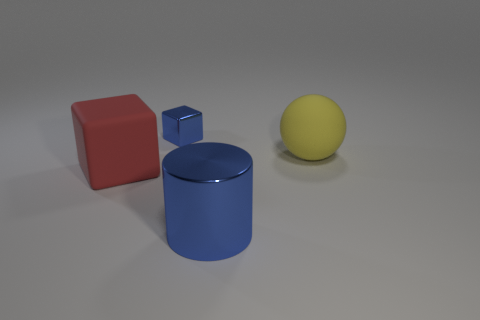Add 2 blue cubes. How many objects exist? 6 Subtract all cylinders. How many objects are left? 3 Subtract all red things. Subtract all cubes. How many objects are left? 1 Add 3 blue metallic blocks. How many blue metallic blocks are left? 4 Add 4 green things. How many green things exist? 4 Subtract 0 cyan balls. How many objects are left? 4 